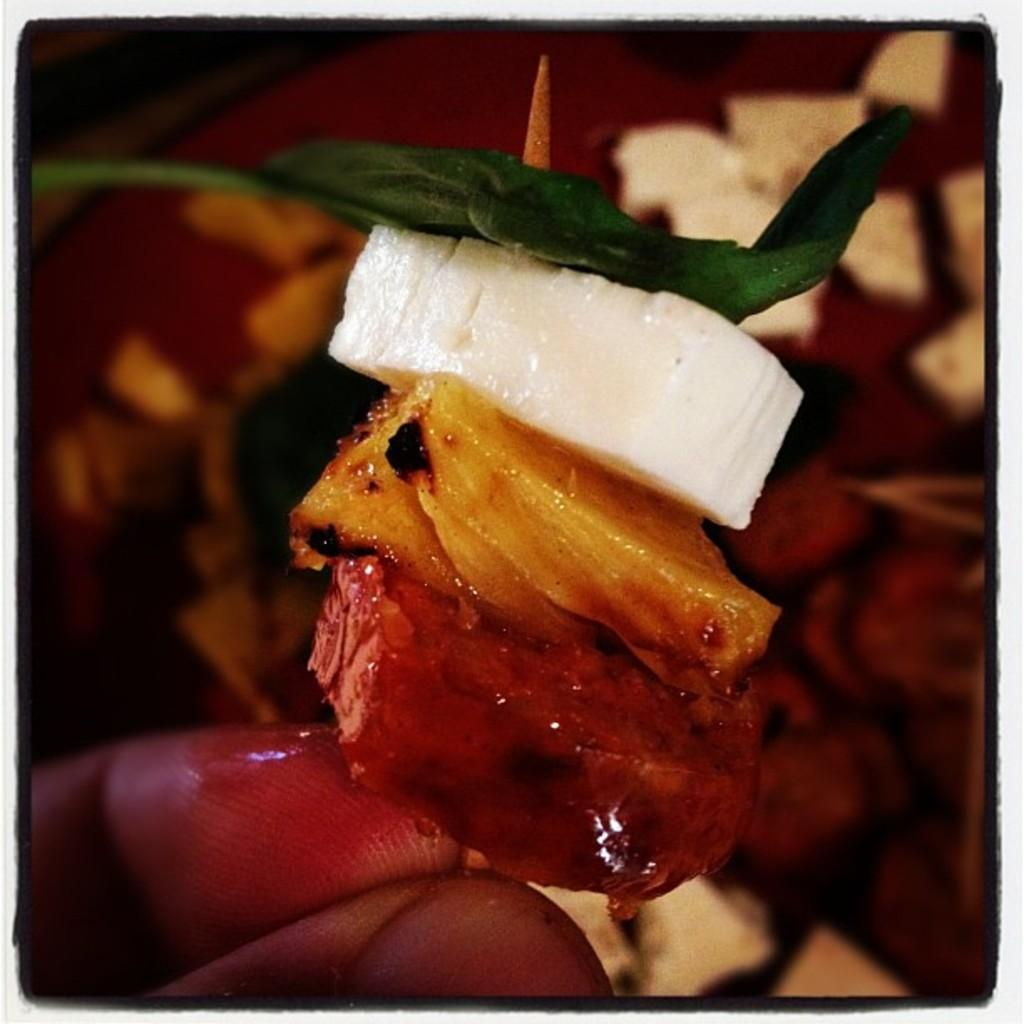What is present in the image? There is a person in the image. What is the person holding in their hand? The person has food in their hand. Can you describe the background of the image? The background of the image is blurry. What type of curtain can be seen hanging from the ceiling in the image? There is no curtain present in the image. Is there a cactus visible in the image? No, there is no cactus present in the image. 